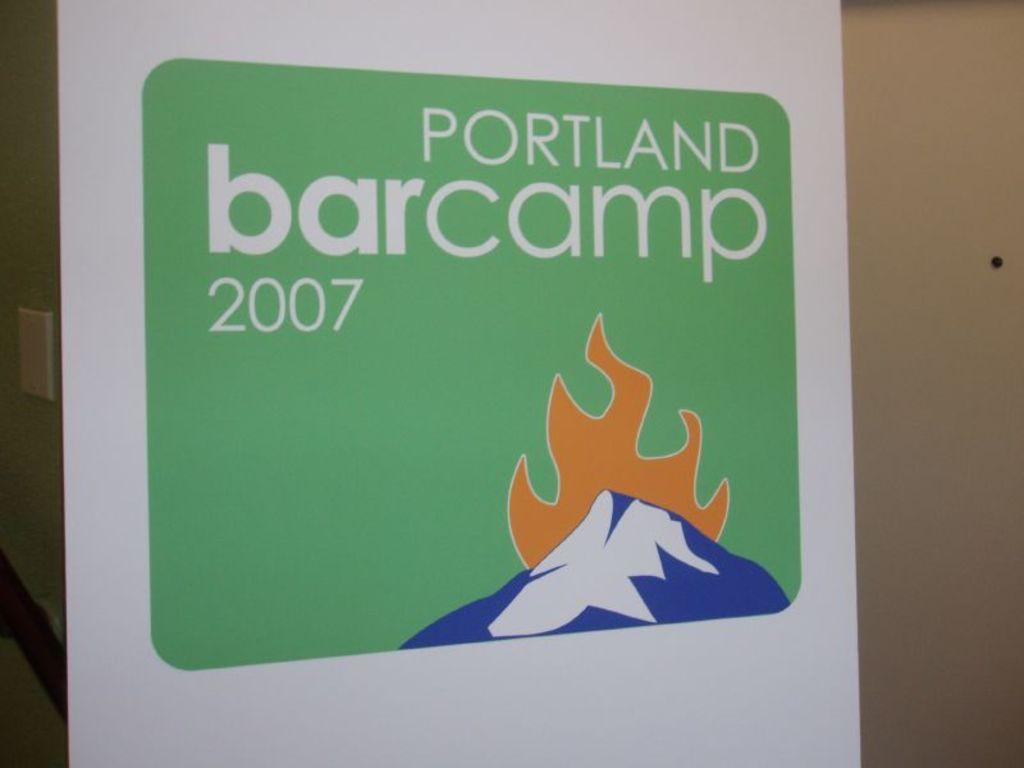<image>
Offer a succinct explanation of the picture presented. a green photo with the word Portland on it 